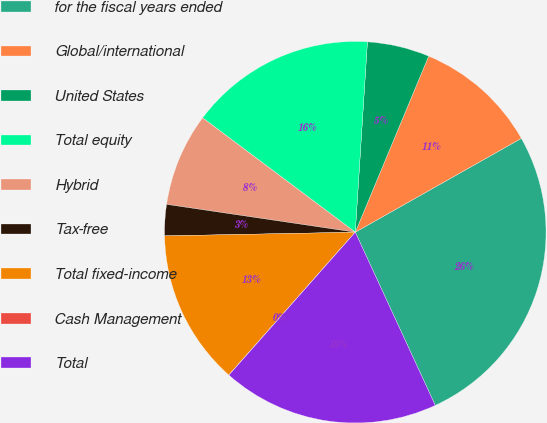<chart> <loc_0><loc_0><loc_500><loc_500><pie_chart><fcel>for the fiscal years ended<fcel>Global/international<fcel>United States<fcel>Total equity<fcel>Hybrid<fcel>Tax-free<fcel>Total fixed-income<fcel>Cash Management<fcel>Total<nl><fcel>26.3%<fcel>10.53%<fcel>5.27%<fcel>15.78%<fcel>7.9%<fcel>2.64%<fcel>13.16%<fcel>0.01%<fcel>18.41%<nl></chart> 